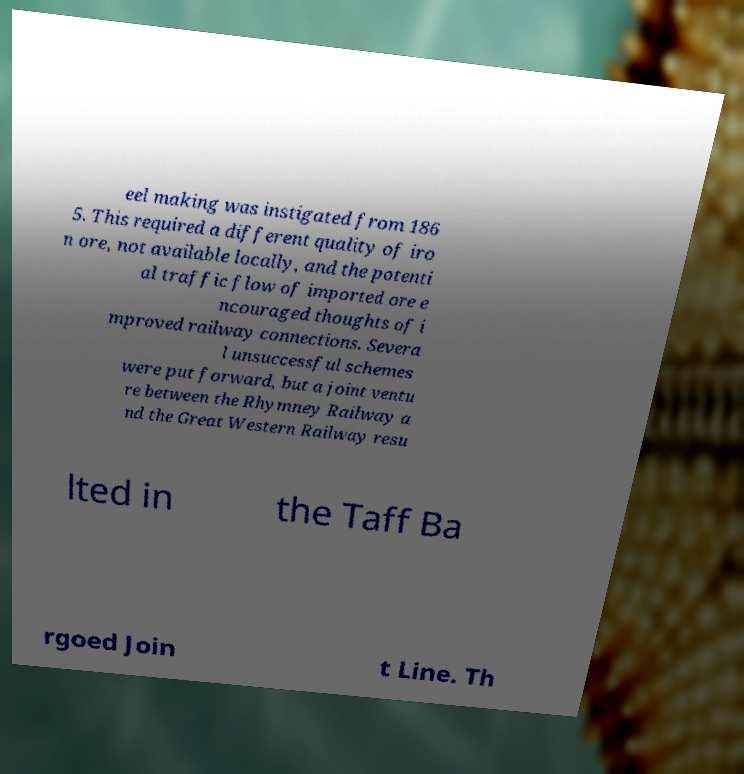What messages or text are displayed in this image? I need them in a readable, typed format. eel making was instigated from 186 5. This required a different quality of iro n ore, not available locally, and the potenti al traffic flow of imported ore e ncouraged thoughts of i mproved railway connections. Severa l unsuccessful schemes were put forward, but a joint ventu re between the Rhymney Railway a nd the Great Western Railway resu lted in the Taff Ba rgoed Join t Line. Th 